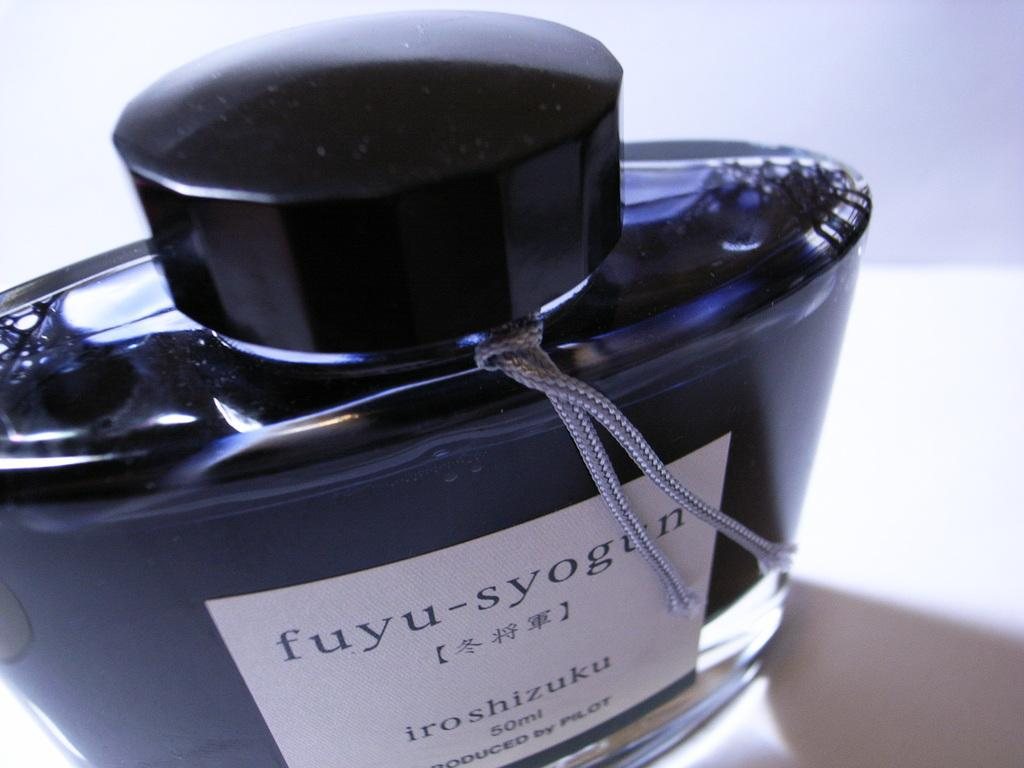<image>
Provide a brief description of the given image. A bottle of fuyu-syogun that is produced by Pilot. 